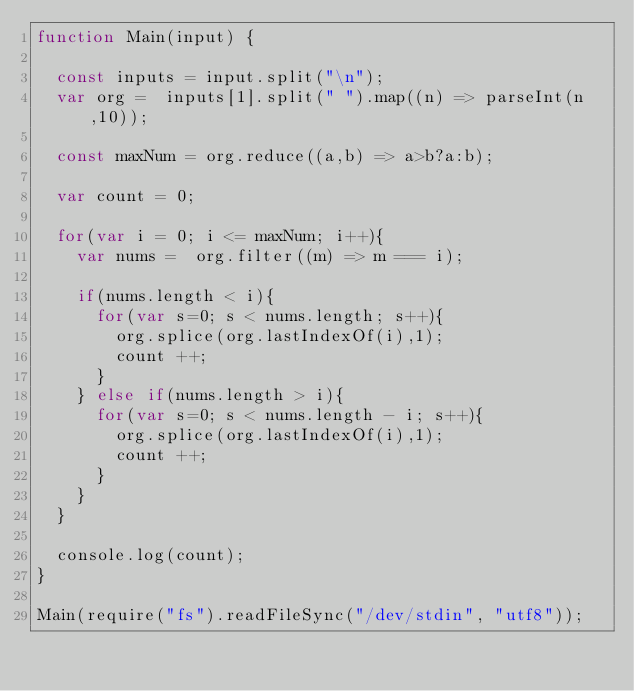<code> <loc_0><loc_0><loc_500><loc_500><_JavaScript_>function Main(input) {

  const inputs = input.split("\n");
  var org =  inputs[1].split(" ").map((n) => parseInt(n,10));

  const maxNum = org.reduce((a,b) => a>b?a:b);

  var count = 0;

  for(var i = 0; i <= maxNum; i++){
    var nums =  org.filter((m) => m === i);

    if(nums.length < i){
      for(var s=0; s < nums.length; s++){
        org.splice(org.lastIndexOf(i),1);
        count ++;
      }
    } else if(nums.length > i){
      for(var s=0; s < nums.length - i; s++){
        org.splice(org.lastIndexOf(i),1);
        count ++;
      }
    }
  }

  console.log(count);
}

Main(require("fs").readFileSync("/dev/stdin", "utf8"));
</code> 